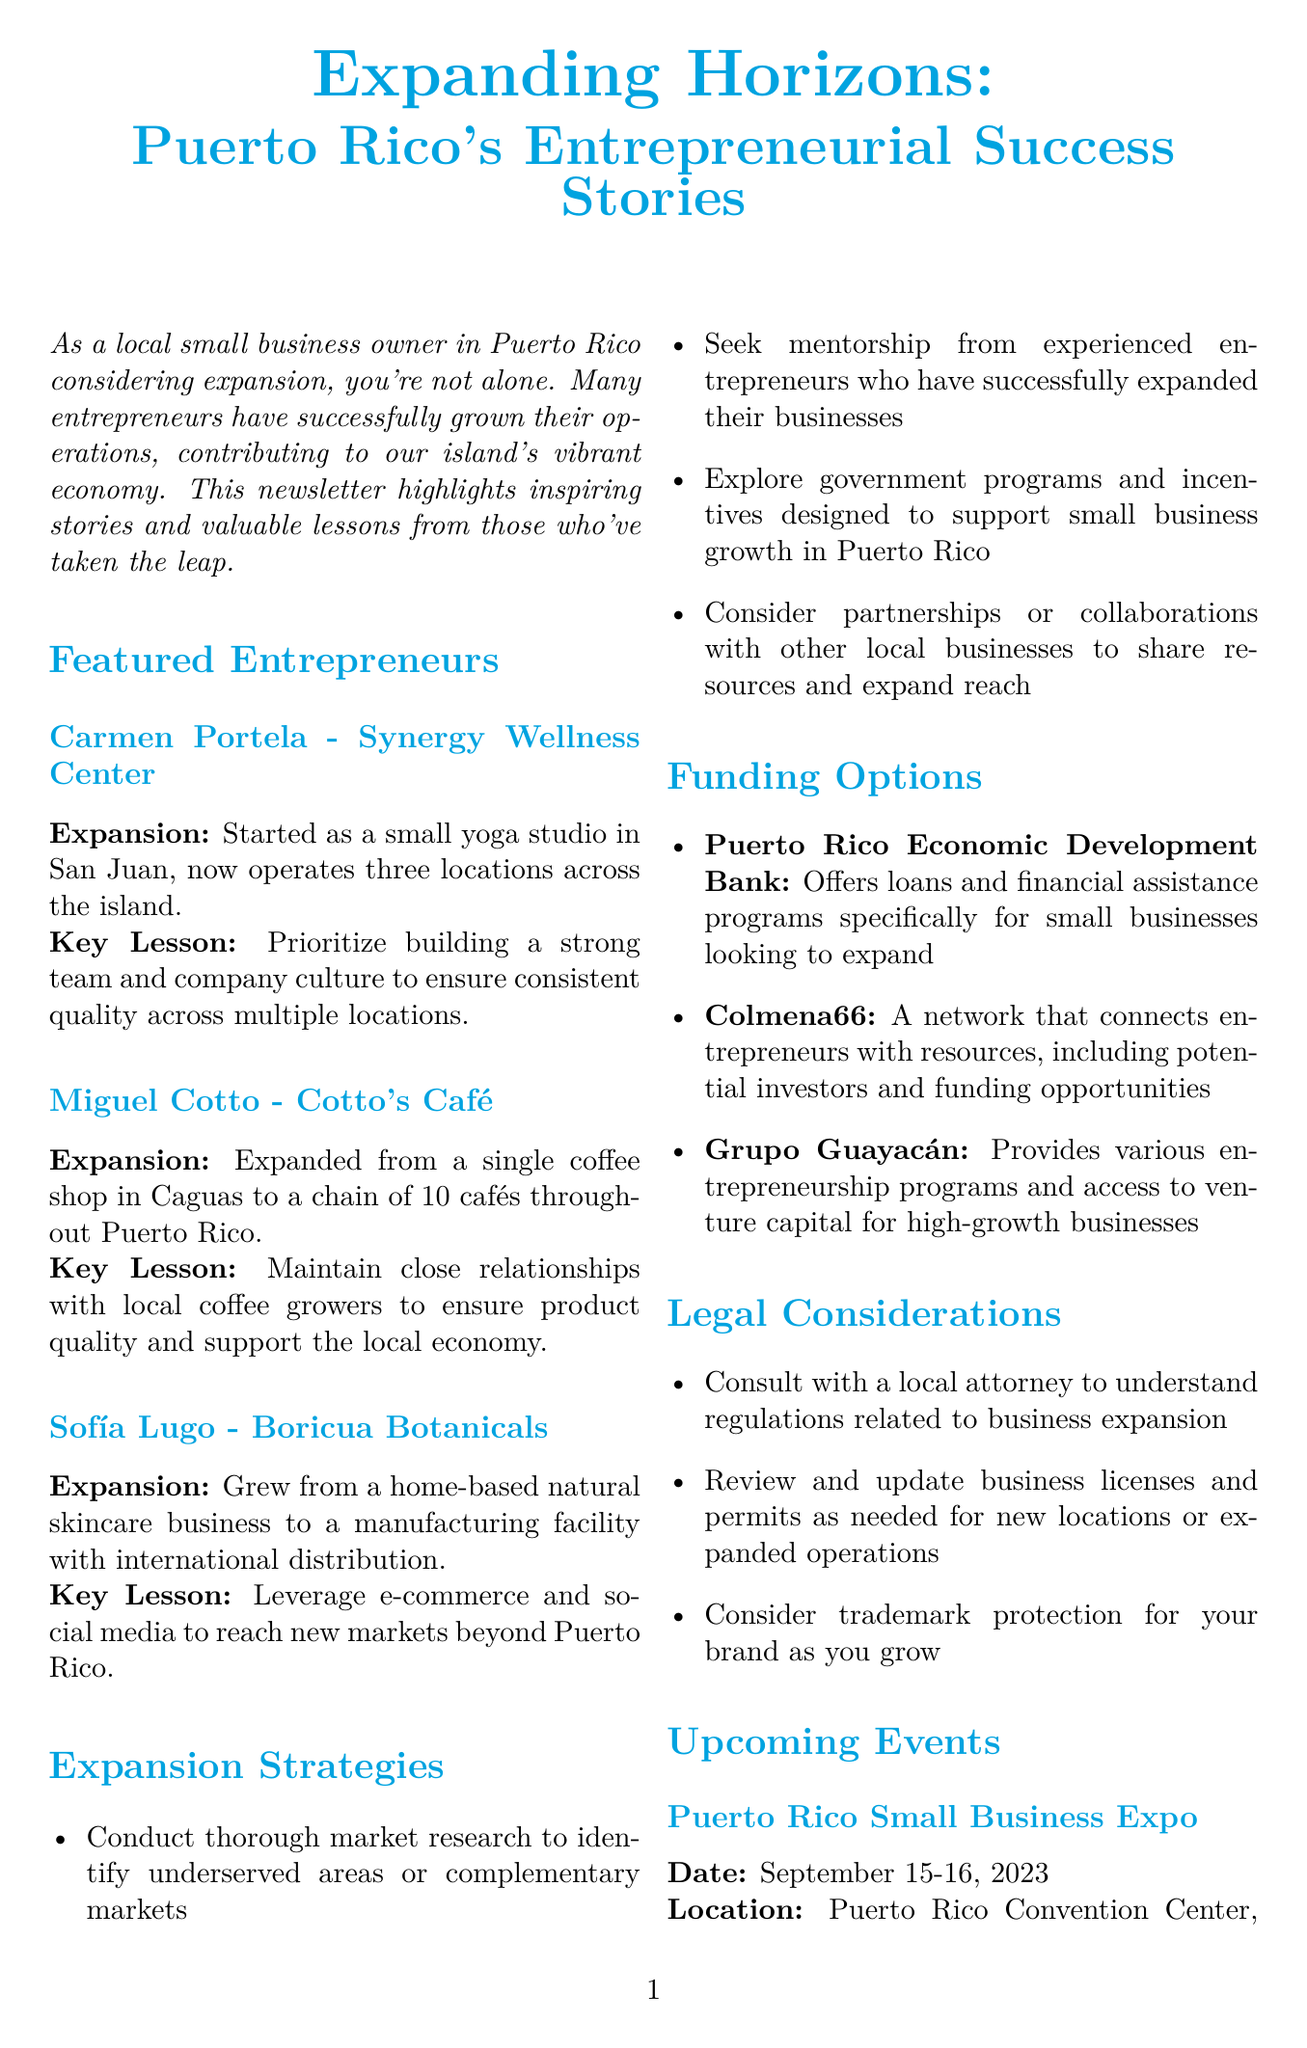What business did Carmen Portela own? Carmen Portela owned the Synergy Wellness Center, as specified in her profile.
Answer: Synergy Wellness Center How many cafés did Miguel Cotto expand to? Miguel Cotto expanded from a single café to a chain of 10 cafés, as noted in his expansion story.
Answer: 10 What is a key lesson from Sofía Lugo's story? Sofía Lugo's key lesson emphasizes leveraging e-commerce and social media for market reach, detailed in her lesson section.
Answer: Leverage e-commerce and social media What is one funding option mentioned for business expansion? The document lists the Puerto Rico Economic Development Bank as a funding option for small businesses seeking expansion.
Answer: Puerto Rico Economic Development Bank When is the Expanding Your Business Workshop? The Expanding Your Business Workshop is scheduled for October 5, 2023, featured in the upcoming events section.
Answer: October 5, 2023 What is a suggested strategy for business expansion? Conducting thorough market research is one suggested strategy mentioned in the expansion strategies list.
Answer: Conduct thorough market research What is the main focus of the Puerto Rico Small Business Expo? The focus of the Puerto Rico Small Business Expo is networking and learning about expansion strategies, as described in the event details.
Answer: Network with successful entrepreneurs Who provides access to venture capital for high-growth businesses? Grupo Guayacán is the organization that provides access to venture capital, as outlined in the funding options section.
Answer: Grupo Guayacán What is an important legal consideration for expansion? Consulting with a local attorney to understand regulations is highlighted as an important legal consideration for expansion.
Answer: Consult with a local attorney 